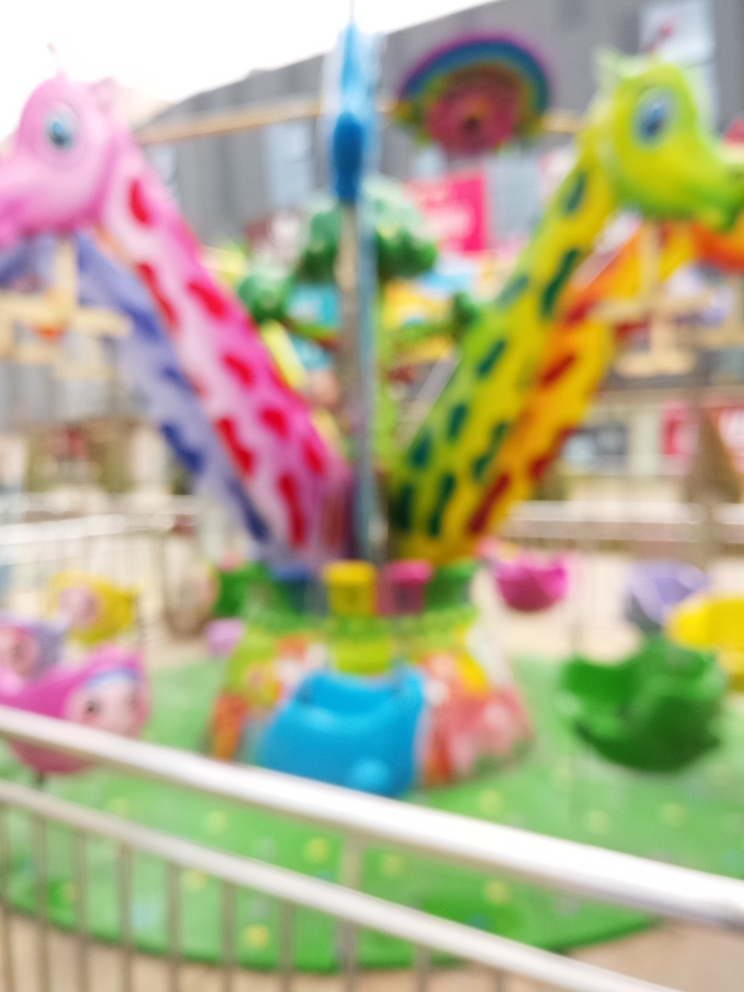Is there any noise in the image? If by 'noise' you're referring to visual noise or graininess within the image, then the answer isn't straightforward due to the image being blurred. Visual noise usually pertains to random variations of brightness or color information in images, which can't be accurately assessed here because the focus is not sharp enough to differentiate between fine details. In more general terms, the image appears to be of a carousel that's out of focus, potentially conveying a sense of motion or activity, which might be interpreted as 'noisy' in a metaphorical sense, but this would not be considered 'noise' in the technical photography or image analysis sense. 